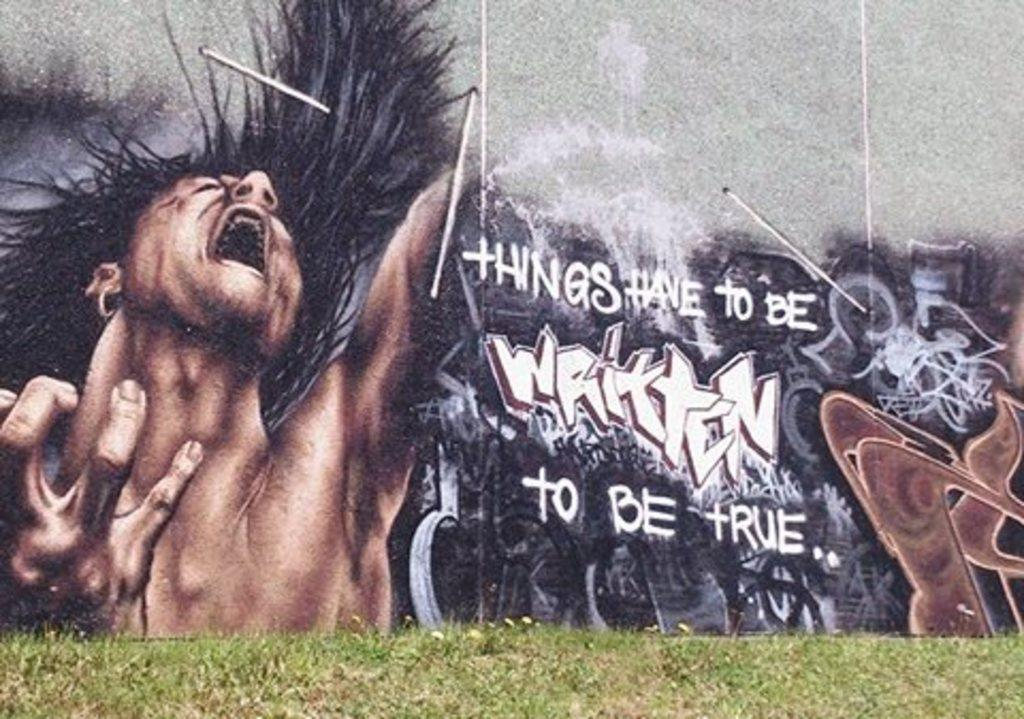<image>
Write a terse but informative summary of the picture. A graffiti painting reads "Things have to be written to be true" 